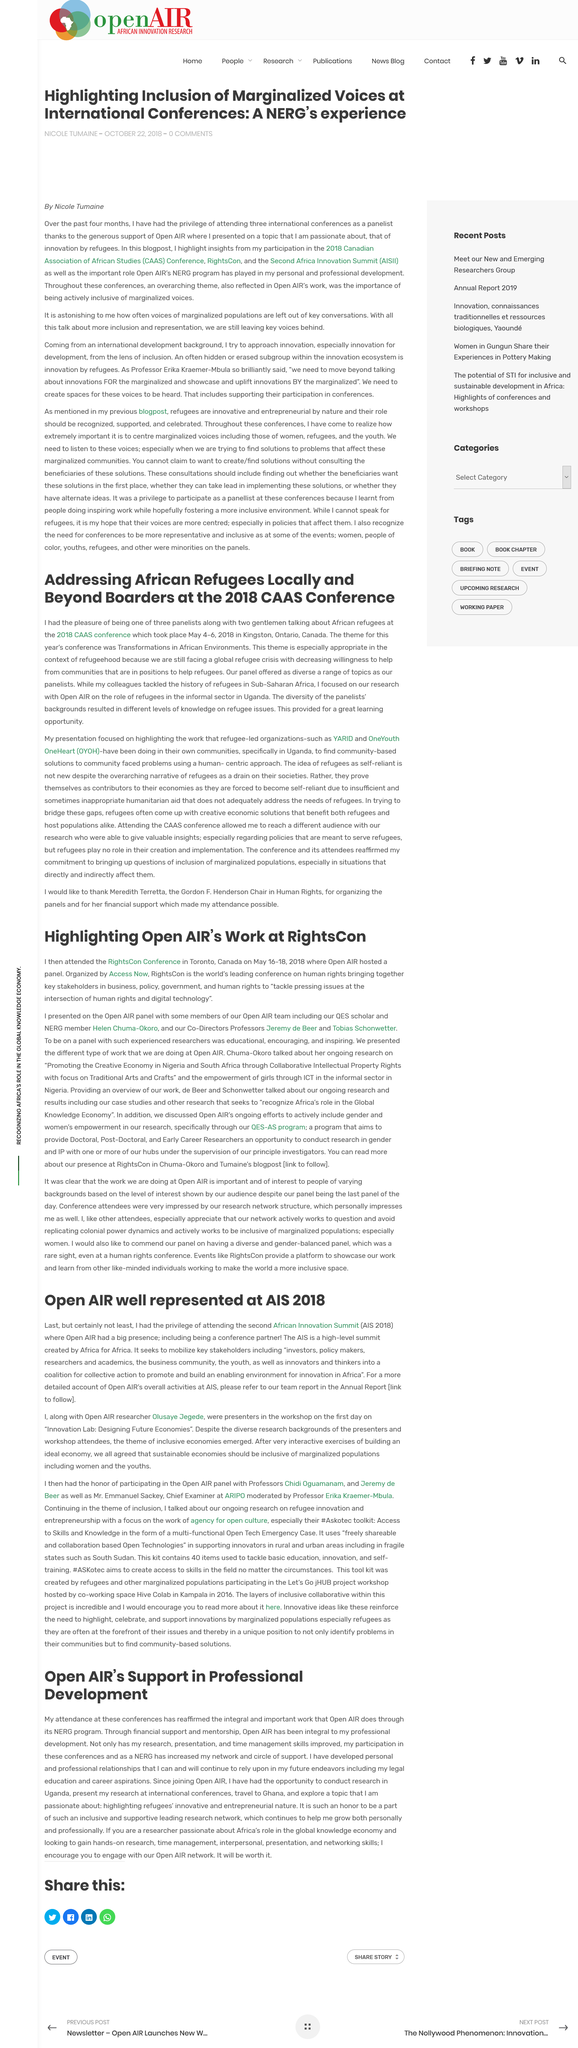Highlight a few significant elements in this photo. The acronym AIS stands for African Innovation Summit, which is a conference focused on promoting innovation and technology in Africa. The Annual Report is a comprehensive source of information regarding the activities of OpenAIR. The author attended three international conferences as a panelist. It is declared that Nicole Tumaine wrote the article. There were three panelists at the conference, and the number of panelists in attendance was three. 